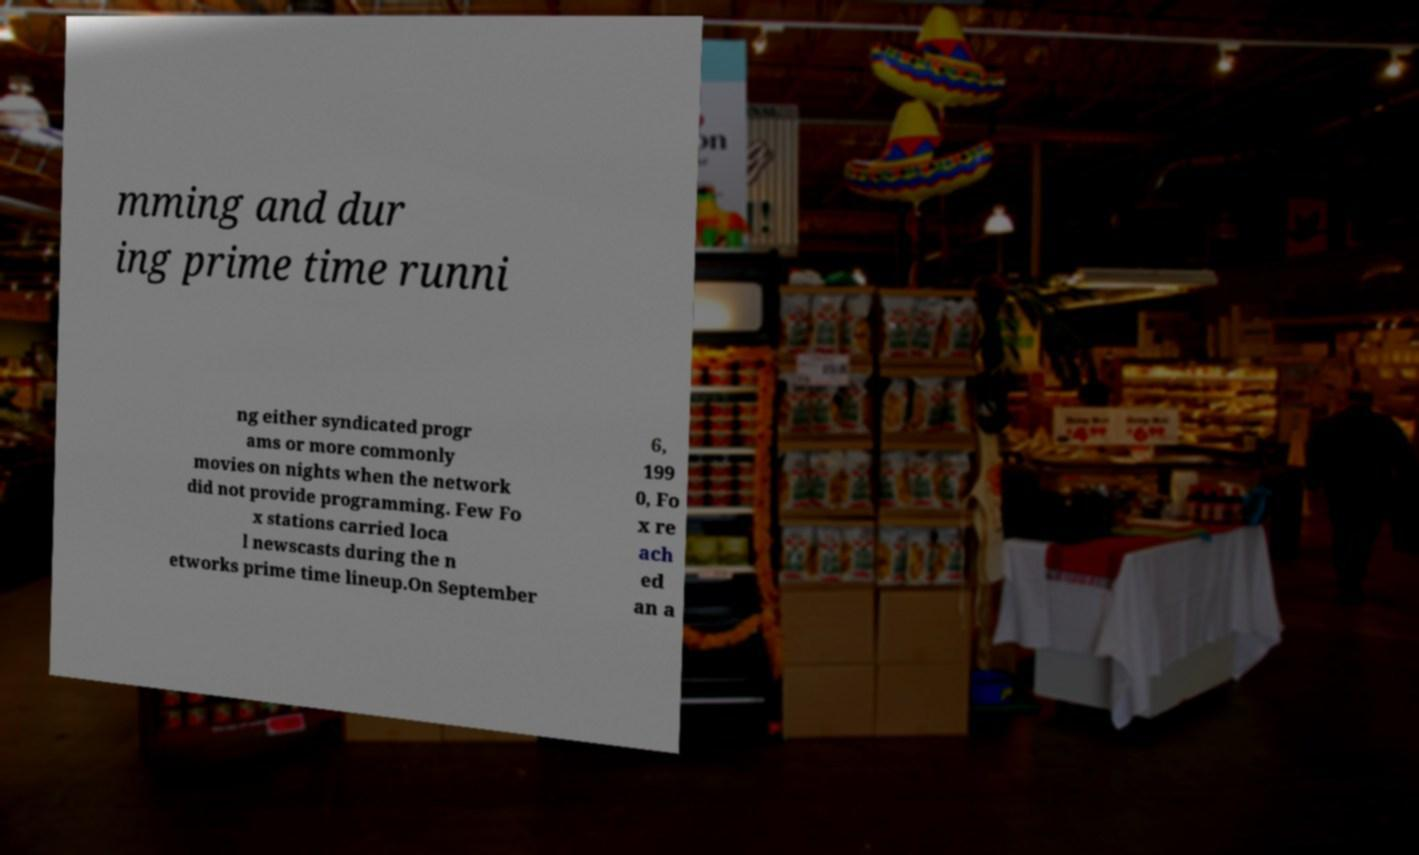Please identify and transcribe the text found in this image. mming and dur ing prime time runni ng either syndicated progr ams or more commonly movies on nights when the network did not provide programming. Few Fo x stations carried loca l newscasts during the n etworks prime time lineup.On September 6, 199 0, Fo x re ach ed an a 